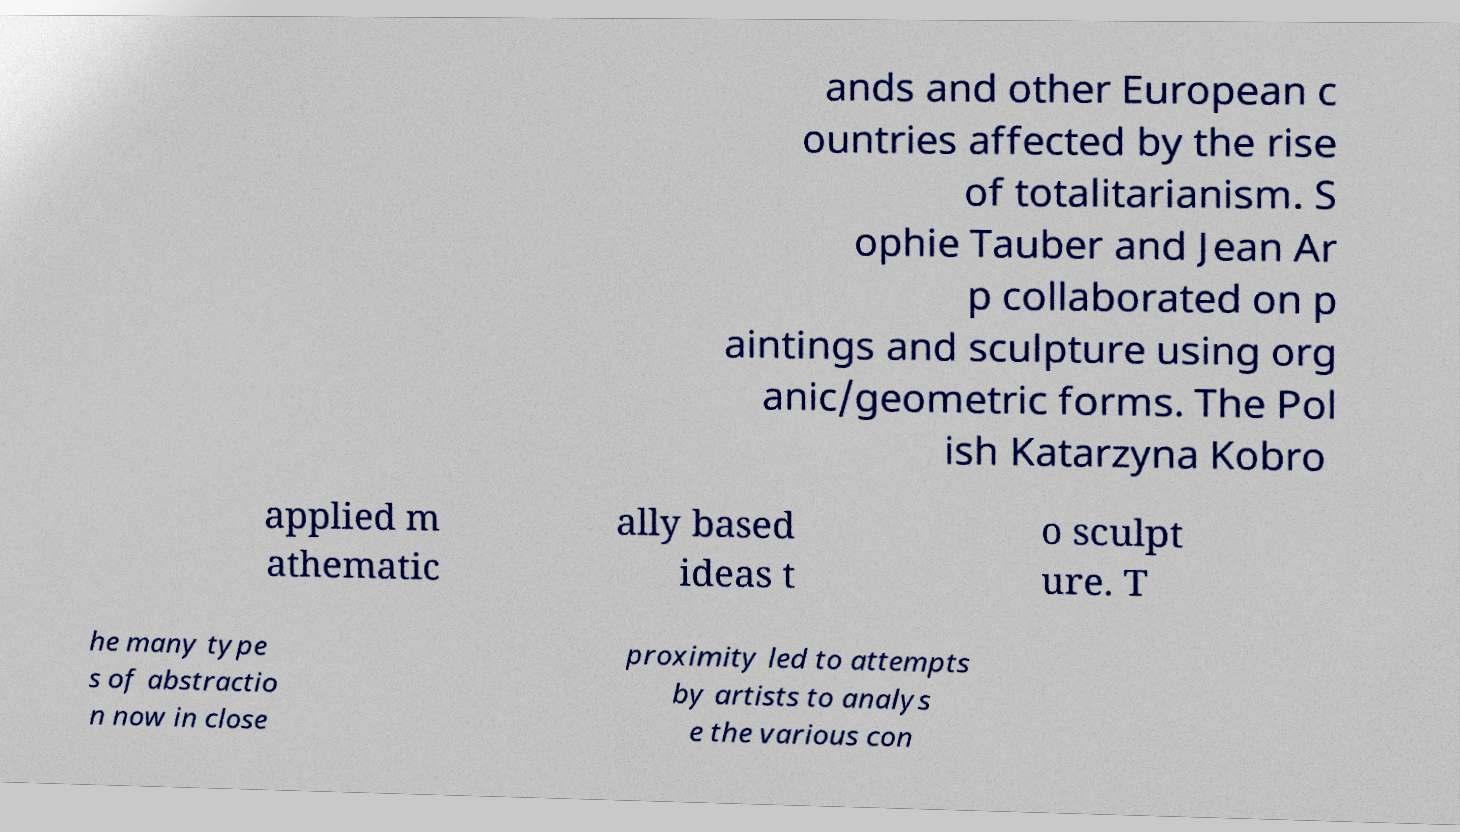Can you accurately transcribe the text from the provided image for me? ands and other European c ountries affected by the rise of totalitarianism. S ophie Tauber and Jean Ar p collaborated on p aintings and sculpture using org anic/geometric forms. The Pol ish Katarzyna Kobro applied m athematic ally based ideas t o sculpt ure. T he many type s of abstractio n now in close proximity led to attempts by artists to analys e the various con 